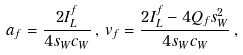Convert formula to latex. <formula><loc_0><loc_0><loc_500><loc_500>a _ { f } = \frac { 2 I ^ { f } _ { L } } { 4 s _ { W } c _ { W } } \, , \, v _ { f } = \frac { 2 I ^ { f } _ { L } - 4 Q _ { f } s _ { W } ^ { 2 } } { 4 s _ { W } c _ { W } } \, ,</formula> 